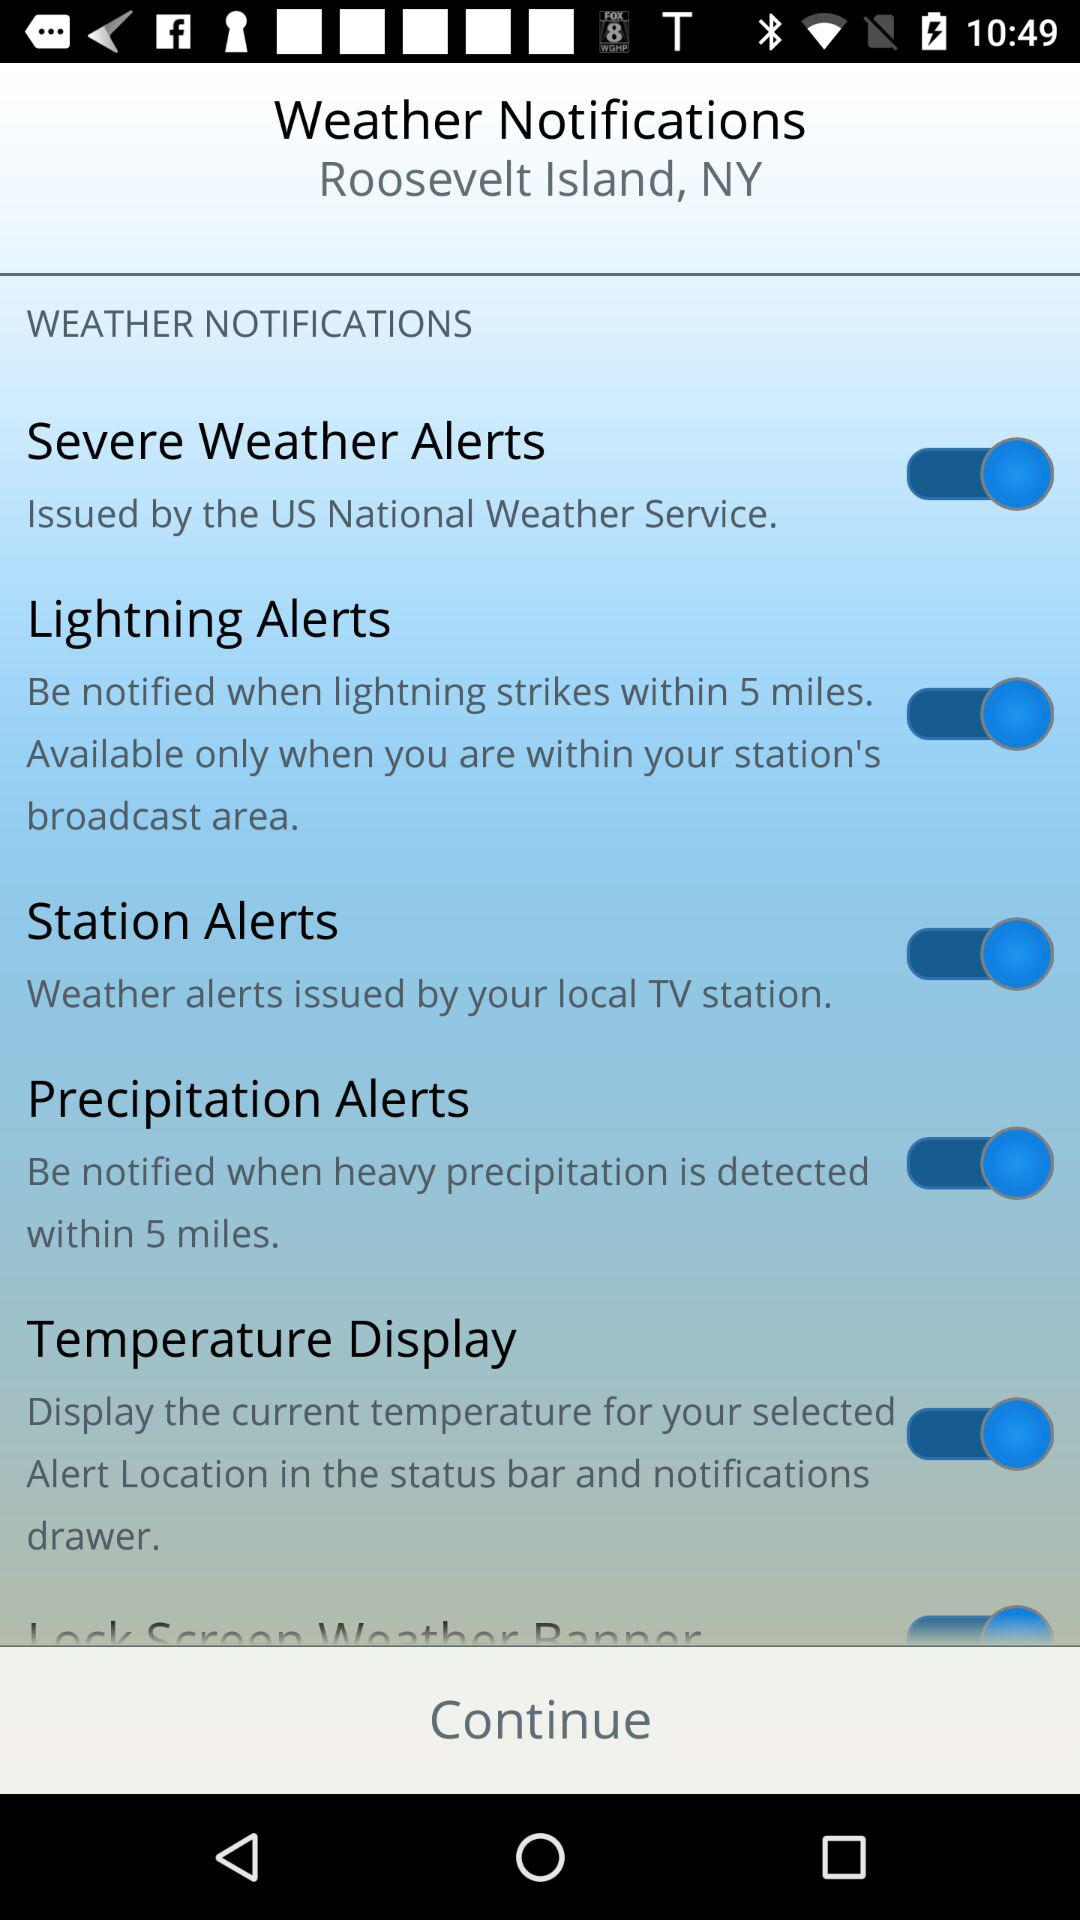What is the status of the "Lightning Alerts" notification setting? The status is "on". 